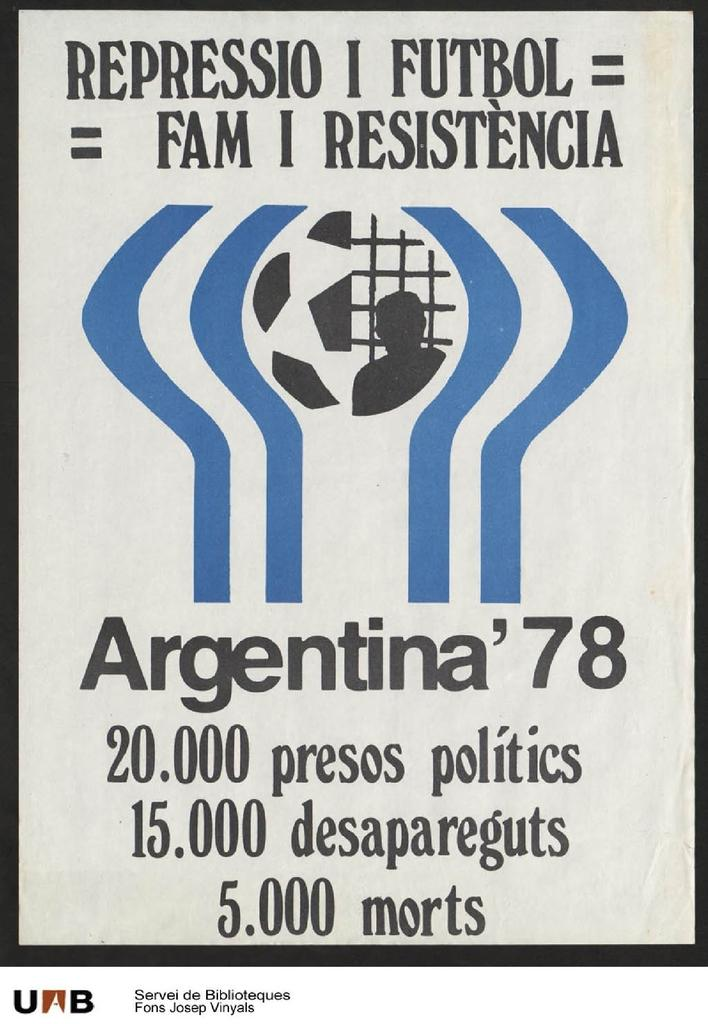What is present on the poster in the image? There is a poster in the image. What color is the text on the poster? The text on the poster is written in black color. What is the color of the background in the image? The background of the image is white in color. How does the brain contribute to the trade depicted on the poster? There is no mention of trade or a brain in the image, as it only features a poster with text written in black color against a white background. 